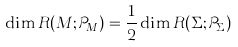Convert formula to latex. <formula><loc_0><loc_0><loc_500><loc_500>\dim R ( M ; \mathcal { P } _ { M } ) = \frac { 1 } { 2 } \dim R ( \Sigma ; \mathcal { P } _ { \Sigma } )</formula> 